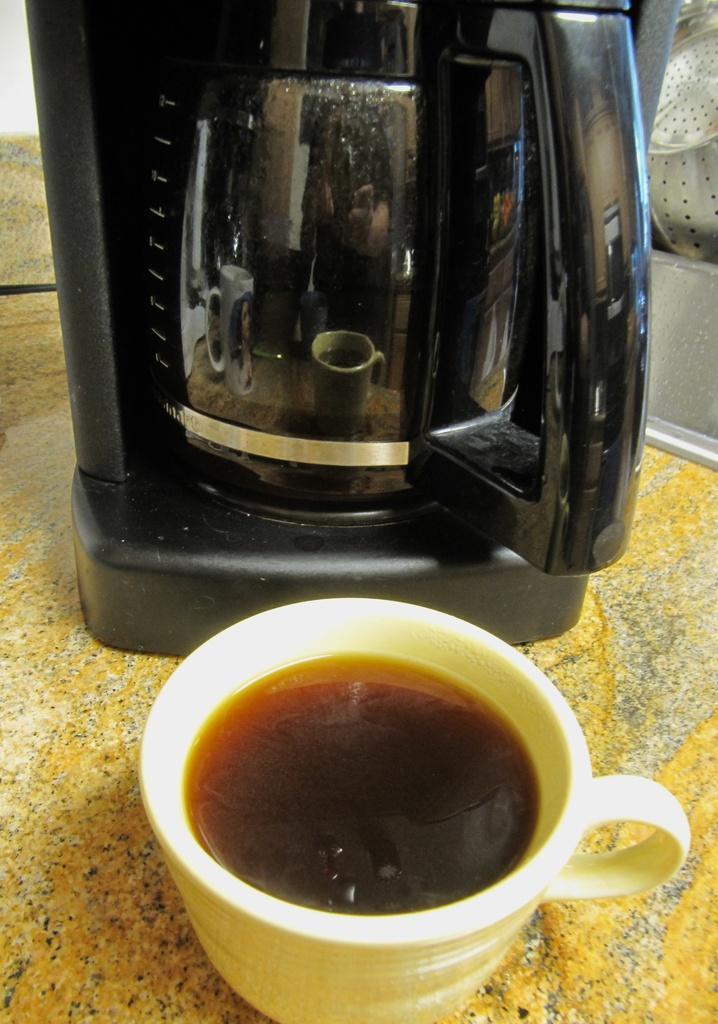Could you give a brief overview of what you see in this image? In this image there is a coffee cup and a kettle on a surface. 